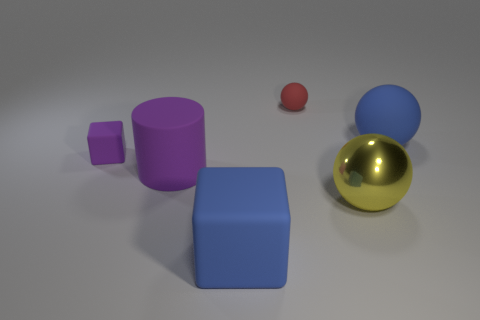Subtract all large balls. How many balls are left? 1 Add 3 large gray cubes. How many objects exist? 9 Subtract all blocks. How many objects are left? 4 Subtract all tiny cyan objects. Subtract all big blue matte objects. How many objects are left? 4 Add 3 large blue rubber spheres. How many large blue rubber spheres are left? 4 Add 3 blue cubes. How many blue cubes exist? 4 Subtract 0 green balls. How many objects are left? 6 